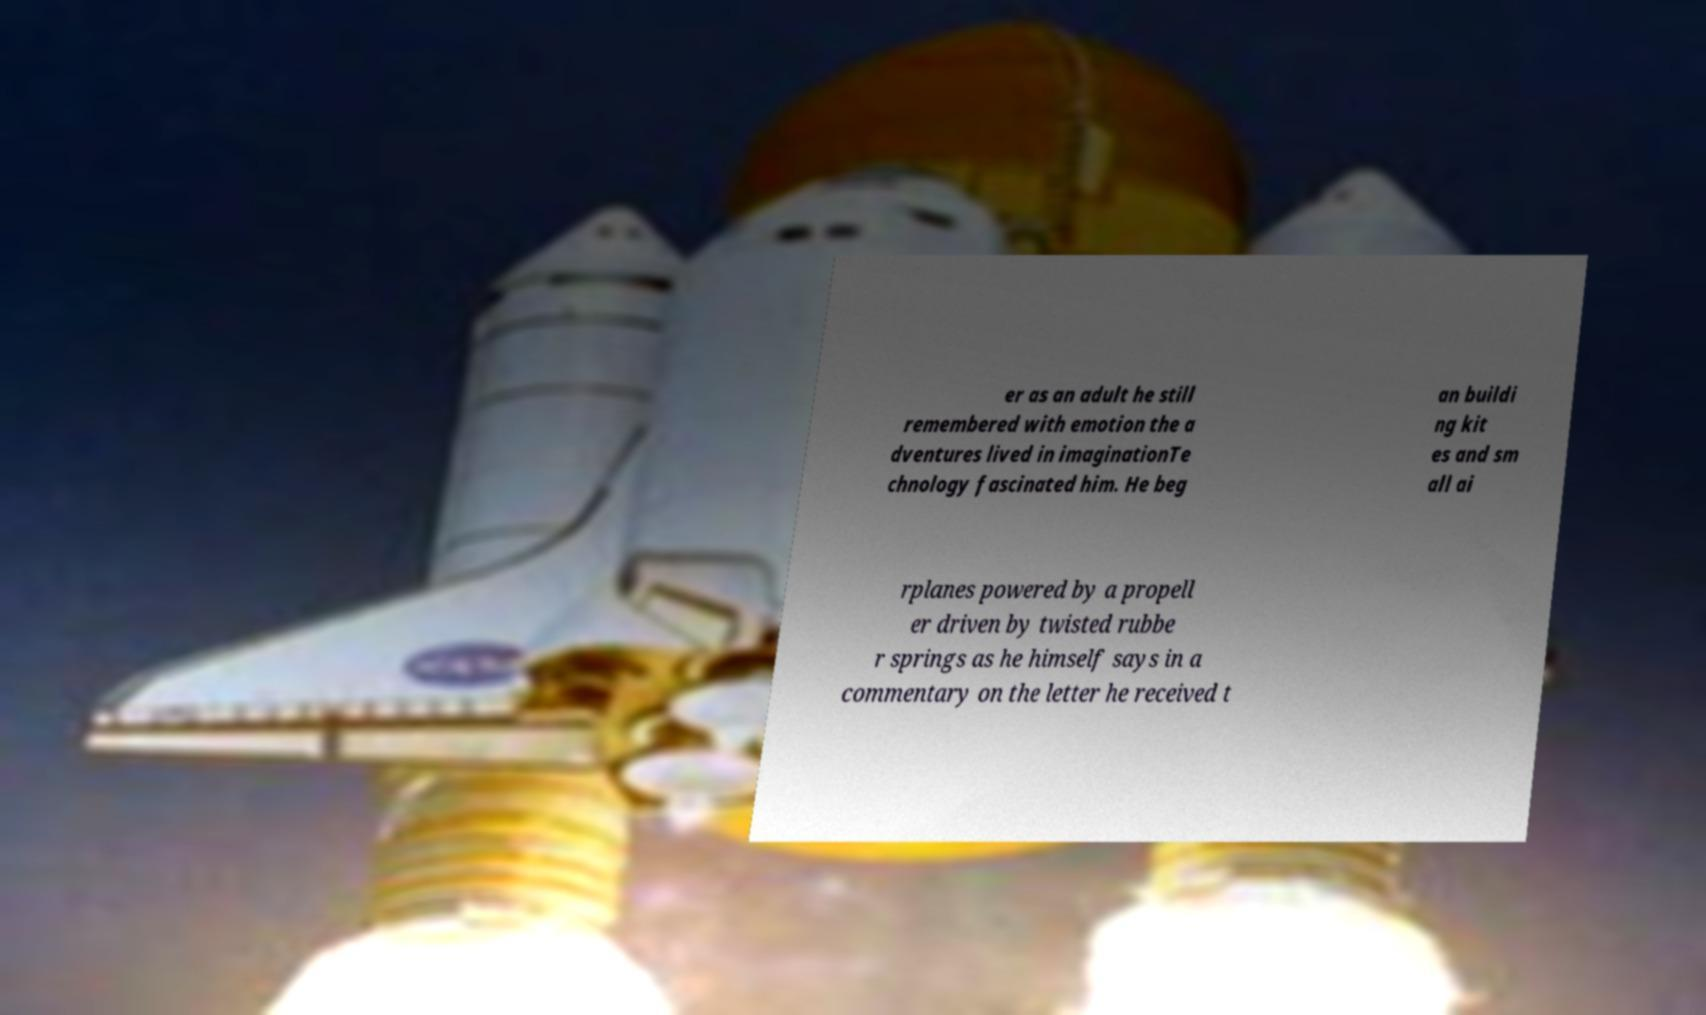Can you read and provide the text displayed in the image?This photo seems to have some interesting text. Can you extract and type it out for me? er as an adult he still remembered with emotion the a dventures lived in imaginationTe chnology fascinated him. He beg an buildi ng kit es and sm all ai rplanes powered by a propell er driven by twisted rubbe r springs as he himself says in a commentary on the letter he received t 